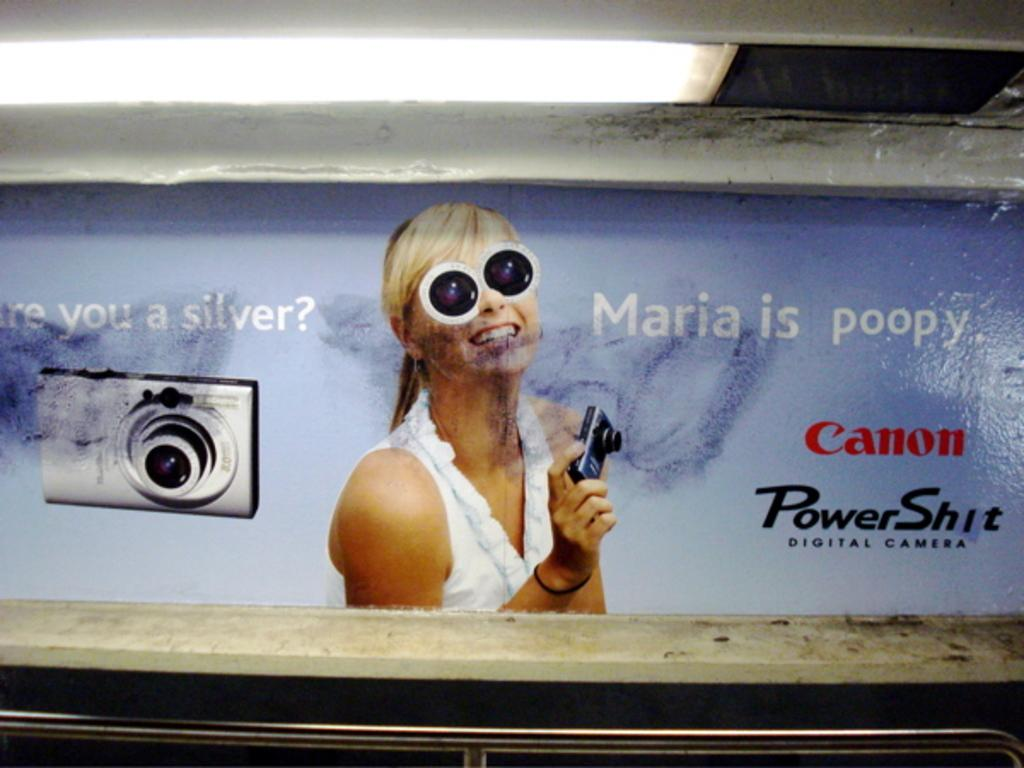What is the main subject of the image? The main subject of the image is a poster attached to a wall. What can be seen on the poster? There are words on the poster, and a person smiling while holding a camera. What is the condition of the light in the image? There is light visible in the image. What object can be seen in the image besides the poster? There is an iron rod in the image. What type of rail can be seen in the image? There is no rail present in the image; it features a poster with a person holding a camera. Can you describe the secretary's outfit in the image? There is no secretary present in the image; it features a poster with a person holding a camera. 